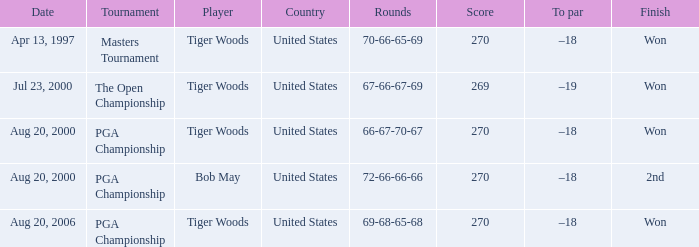Which days had the rounds of 66-67-70-67 noted down? Aug 20, 2000. 